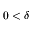<formula> <loc_0><loc_0><loc_500><loc_500>0 < \delta</formula> 